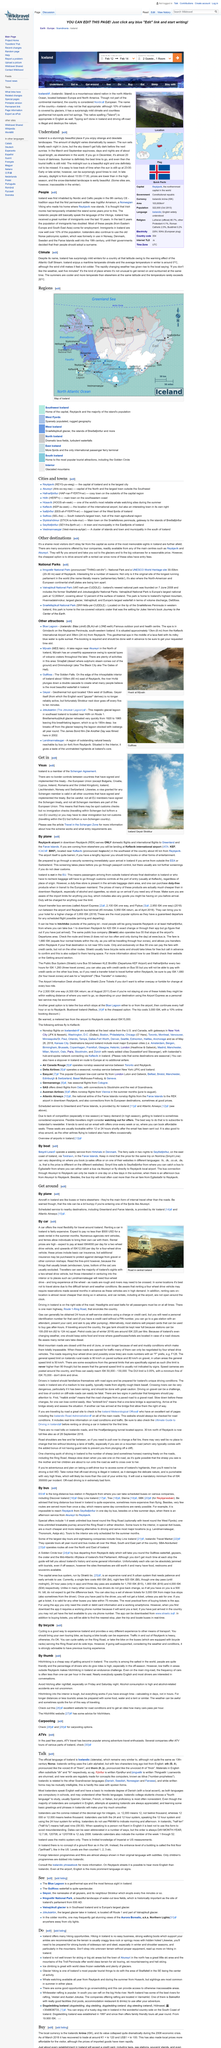Mention a couple of crucial points in this snapshot. Visiting Thingvellir National Park in Iceland is a cost-effective option when traveling by rental car as compared to taking tours as they tend to be more expensive. No, Iceland's glaciers and large volcanoes are not located near the capital city, but they remain popular tourist destinations due to their unique landscapes and stunning beauty. Pingvellir National Park is recognized as a World Heritage Site by UNESCO. There is a bus connection available that travels to Reykjavik, and it runs frequently. The first step is to catch a bus to Egilddtaoir, where you can either continue your journey by taking a bus to Akureyri or fly directly to Reykjavik local airport. Smyril Line operates a weekly service to Hirtshals in Denmark. 